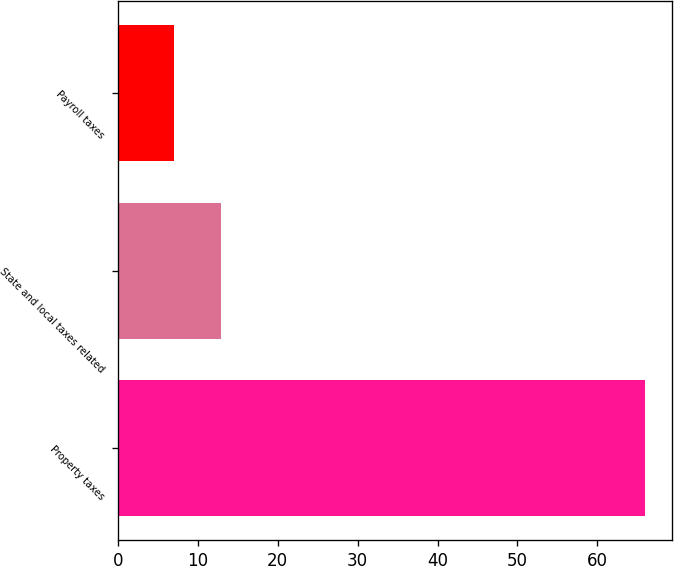Convert chart. <chart><loc_0><loc_0><loc_500><loc_500><bar_chart><fcel>Property taxes<fcel>State and local taxes related<fcel>Payroll taxes<nl><fcel>66<fcel>12.9<fcel>7<nl></chart> 